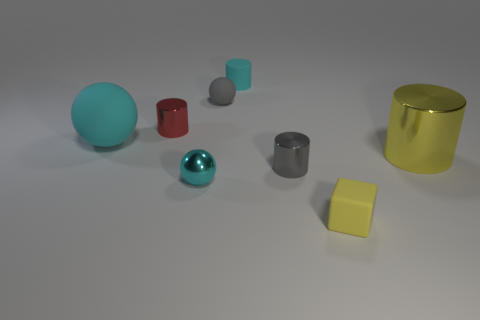Subtract all cyan spheres. How many spheres are left? 1 Add 1 large purple metallic objects. How many objects exist? 9 Subtract all gray spheres. How many spheres are left? 2 Add 5 cubes. How many cubes are left? 6 Add 6 red cylinders. How many red cylinders exist? 7 Subtract 0 yellow spheres. How many objects are left? 8 Subtract all cubes. How many objects are left? 7 Subtract 1 spheres. How many spheres are left? 2 Subtract all purple cylinders. Subtract all green blocks. How many cylinders are left? 4 Subtract all brown cylinders. How many brown spheres are left? 0 